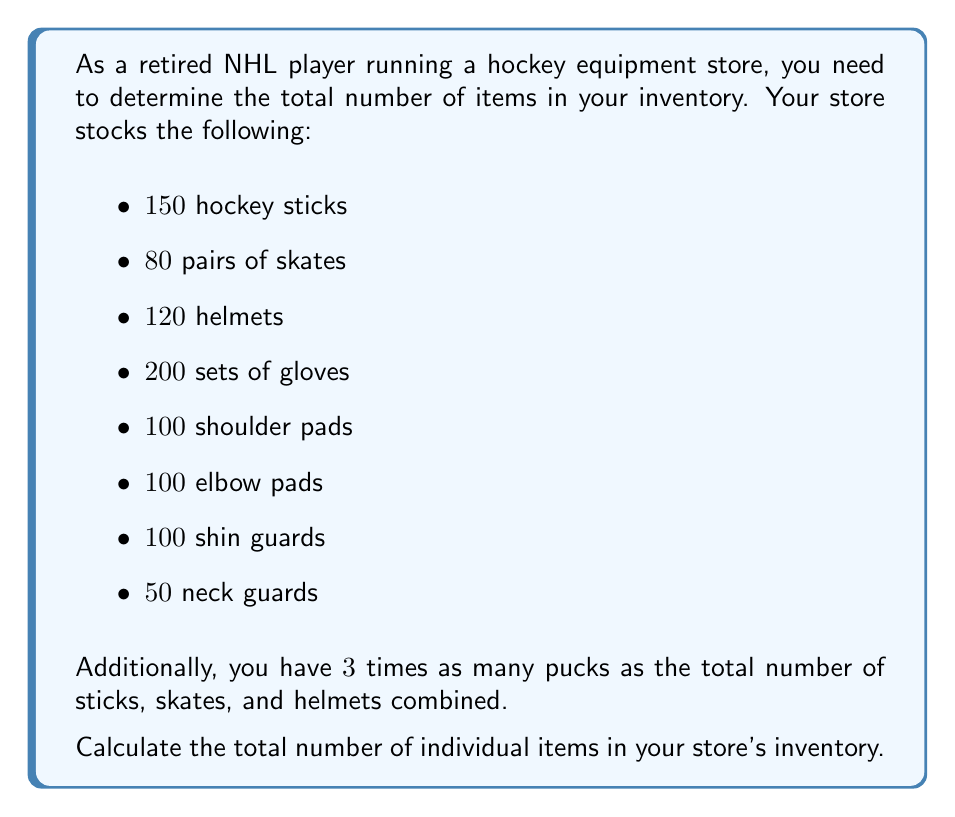Could you help me with this problem? To solve this problem, we'll follow these steps:

1. Count the given items:
   $$150 + 80 + 120 + 200 + 100 + 100 + 100 + 50 = 900$$ items

2. Calculate the number of pucks:
   - First, find the total of sticks, skates, and helmets:
     $$150 + 80 + 120 = 350$$
   - Then, multiply by 3:
     $$350 \times 3 = 1050$$ pucks

3. Sum up all items:
   $$900 + 1050 = 1950$$ total items

Note that we count pairs of skates as single items, as they are typically sold and inventoried as pairs.
Answer: The total number of individual items in the store's inventory is $1950$. 